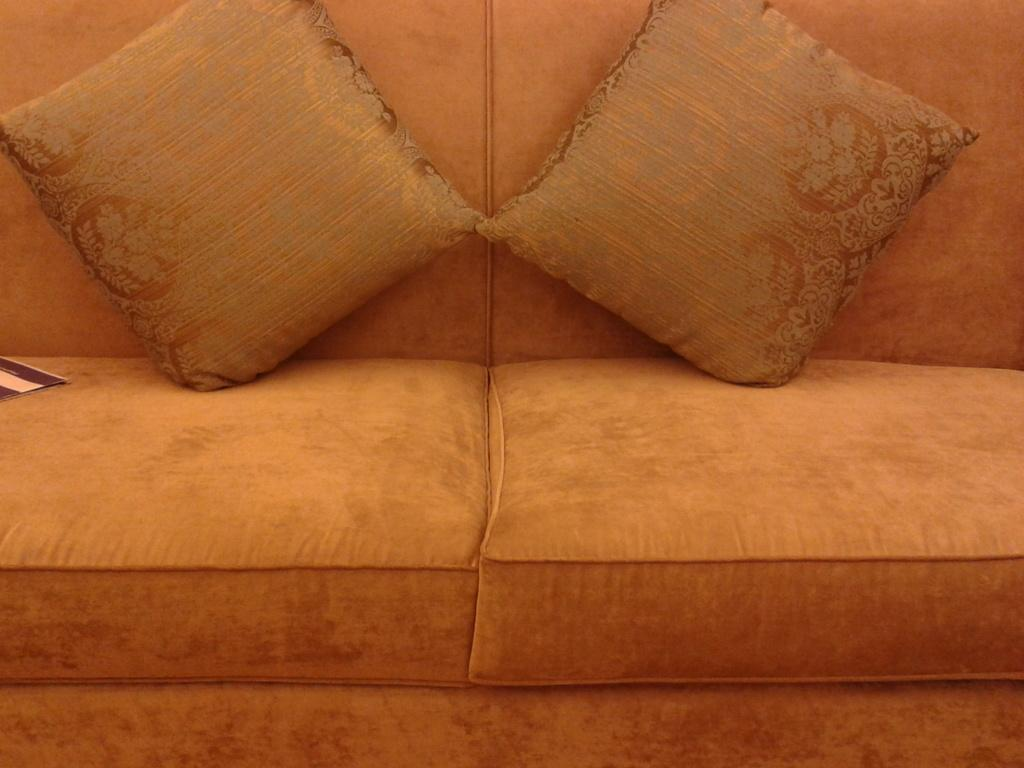What type of furniture is in the image? There is a sofa in the image. What color is the sofa? The sofa is orange in color. Are there any accessories on the sofa? Yes, there are two pillows on the sofa. What type of boundary can be seen in the image? There is no boundary present in the image; it only features a sofa and pillows. How many chairs are visible in the image? There are no chairs visible in the image; it only features a sofa and pillows. 